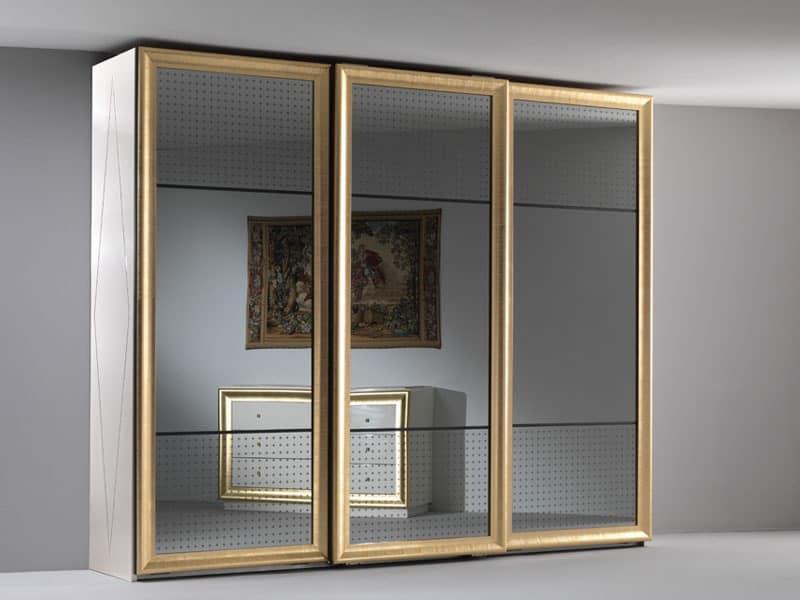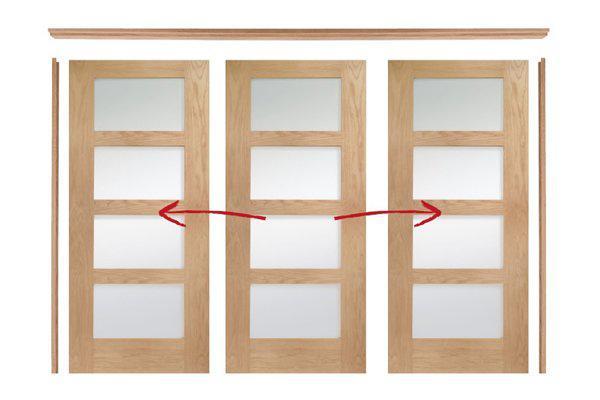The first image is the image on the left, the second image is the image on the right. Examine the images to the left and right. Is the description "The door in one of the images is ajar." accurate? Answer yes or no. No. The first image is the image on the left, the second image is the image on the right. Analyze the images presented: Is the assertion "An image shows a silver-framed sliding door unit with three plain glass panels." valid? Answer yes or no. No. 